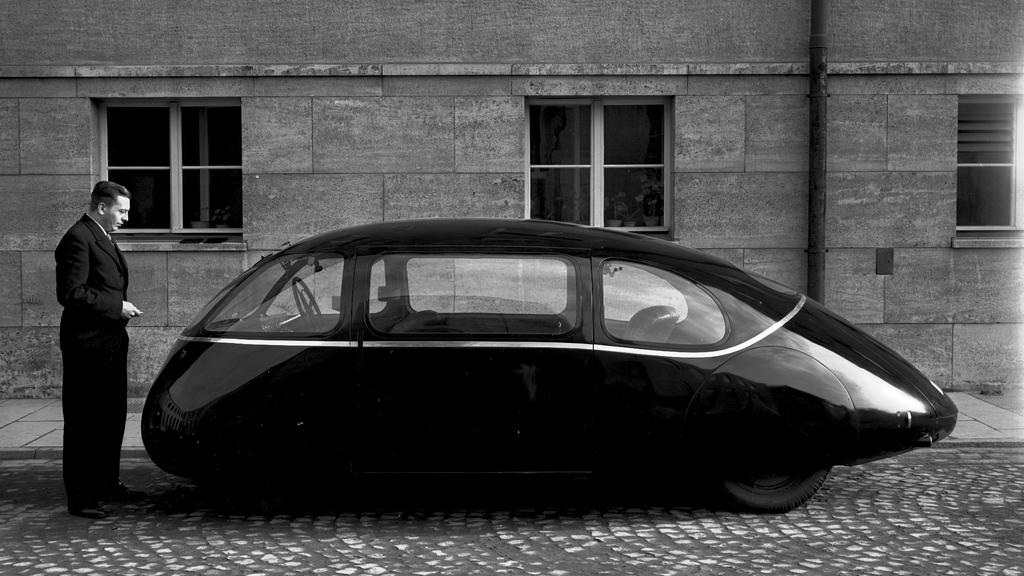What type of vehicle is in the picture? There is a black color vehicle in the picture. Who is present in the picture besides the vehicle? A man is standing on the ground in the picture. What can be seen in the background of the picture? There is a wall with windows in the background of the picture. What is the color scheme of the picture? The picture is black and white in color. What songs can be heard playing from the vehicle in the picture? There is no indication in the image that the vehicle is playing any songs, so it cannot be determined from the picture. 